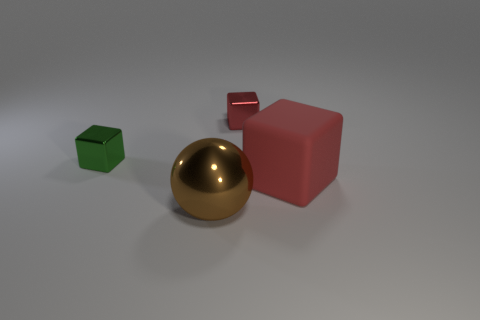There is a large ball left of the shiny object that is right of the big object that is in front of the red matte block; what is its color?
Keep it short and to the point. Brown. There is a cube that is left of the cube behind the tiny green shiny block; what is its size?
Keep it short and to the point. Small. What material is the object that is on the left side of the red metal thing and behind the big cube?
Keep it short and to the point. Metal. There is a green thing; is its size the same as the object that is right of the red metal cube?
Your answer should be very brief. No. Is there a red matte thing?
Your answer should be compact. Yes. What is the material of the other small red thing that is the same shape as the red matte thing?
Offer a terse response. Metal. What size is the shiny block on the right side of the thing that is in front of the large object behind the large shiny sphere?
Offer a terse response. Small. There is a small red shiny cube; are there any big shiny objects in front of it?
Your response must be concise. Yes. What is the size of the green block that is made of the same material as the big sphere?
Provide a succinct answer. Small. What number of other tiny things are the same shape as the green thing?
Your response must be concise. 1. 